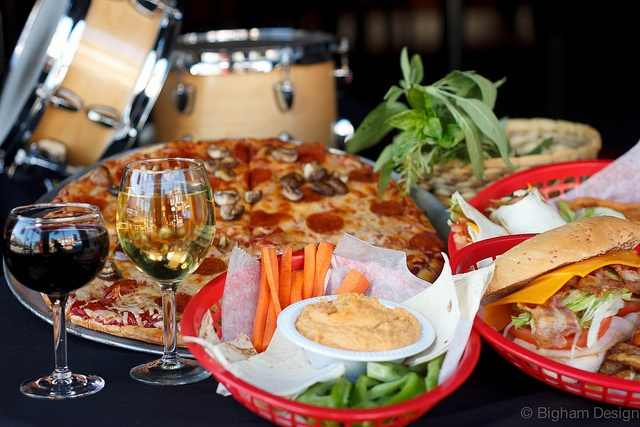Describe the objects in this image and their specific colors. I can see bowl in black, lightgray, tan, brown, and lightpink tones, pizza in black, brown, maroon, and gray tones, sandwich in black, tan, brown, and maroon tones, wine glass in black, brown, gray, and maroon tones, and wine glass in black, gray, and darkgray tones in this image. 